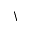<formula> <loc_0><loc_0><loc_500><loc_500>\</formula> 